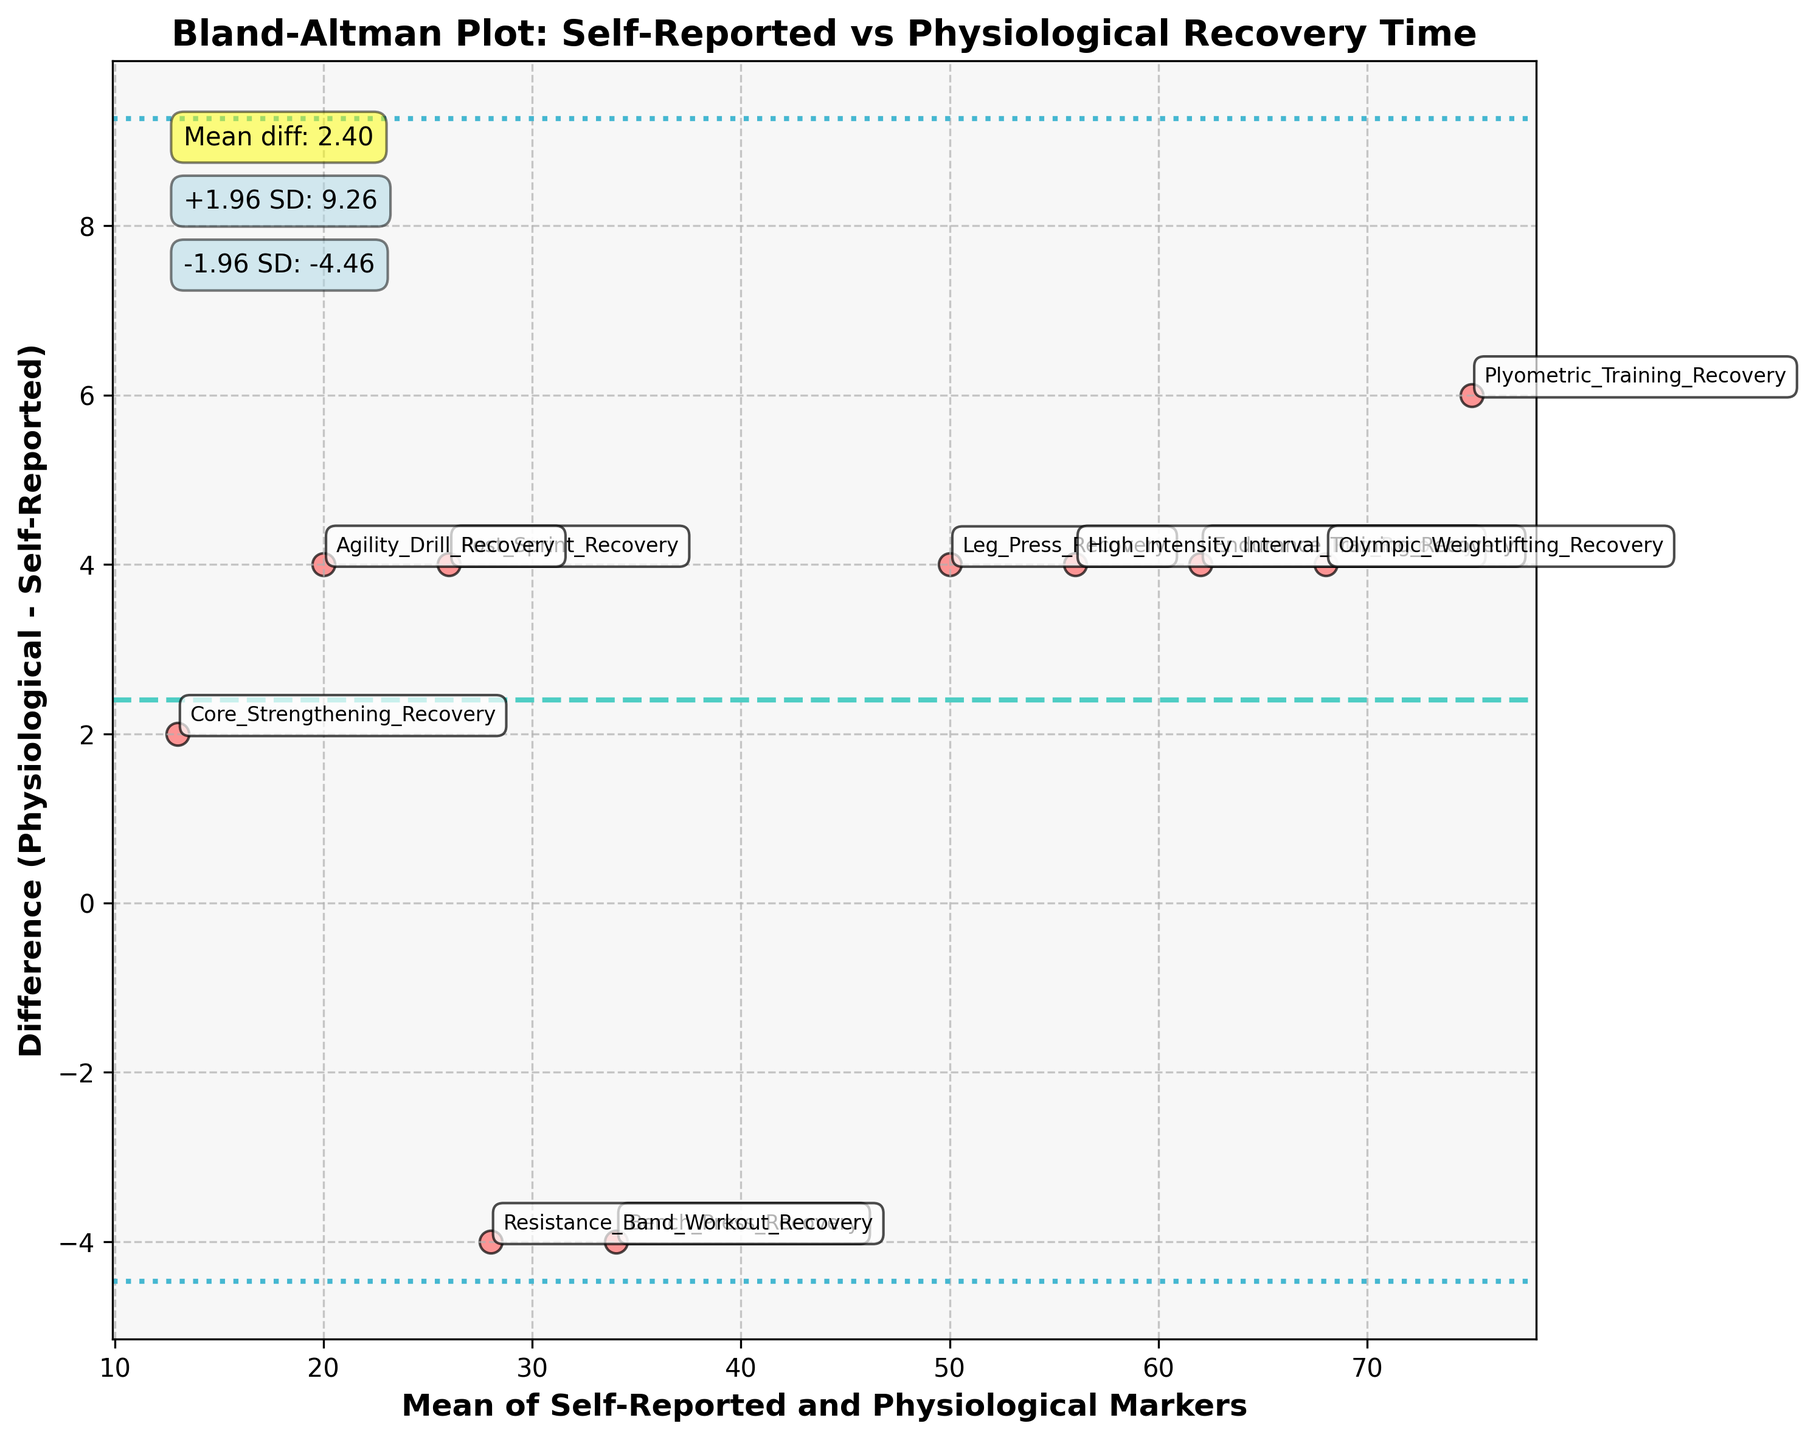What's the title of the figure? The title of the figure is given at the top of the plot and reads: "Bland-Altman Plot: Self-Reported vs Physiological Recovery Time".
Answer: Bland-Altman Plot: Self-Reported vs Physiological Recovery Time How many data points are there in the plot? The number of data points can be counted based on the number of scatter points in the plot. Each point represents a method of recovery assessment.
Answer: 10 What do the dashed and dotted lines represent? The dashed line represents the mean difference (bias) between the self-reported and physiological recovery times, while the dotted lines represent the limits of agreement (mean difference ± 1.96 * standard deviation of the differences).
Answer: Mean difference and limits of agreement What is the mean difference indicated by the dashed line? The mean difference is annotated on the plot itself near a yellow box stating "Mean diff: x.xx", where x.xx is the mean difference value.
Answer: ~3.6 Are most of the differences within the limits of agreement? To determine this, visually compare the differences (y-axis values) of the points to the dotted lines. If most points fall between the dotted lines, then they are within the limits of agreement.
Answer: Yes Which method has the largest positive difference between physiological and self-reported recovery times? Identify the point with the highest value on the y-axis (positive difference). The point with the largest positive difference can be cross-referenced with its label.
Answer: Plyometric Training Recovery Which method has the smallest difference between the two measurements? Identify the point closest to the zero line on the y-axis, cross-referenced with its label.
Answer: Bench Press Recovery How do self-reported and physiological recovery times compare overall? Analyze the mean difference line and the spread of data points around it. A positive mean difference with data points mostly above the zero line indicates that physiological markers generally report higher recovery times than self-reported times.
Answer: Physiological times generally higher Do any methods fall outside the limits of agreement? If so, which ones? Check for points that lie outside the dotted lines, which represent the limits of agreement. Identify these points by their positions and labels.
Answer: No What is the range of the limits of agreement? The limits of agreement are indicated by the dotted lines and their corresponding annotations. Subtract the lower limit from the upper limit to find this range.
Answer: ~19.7 (7.1 to 16.1) 